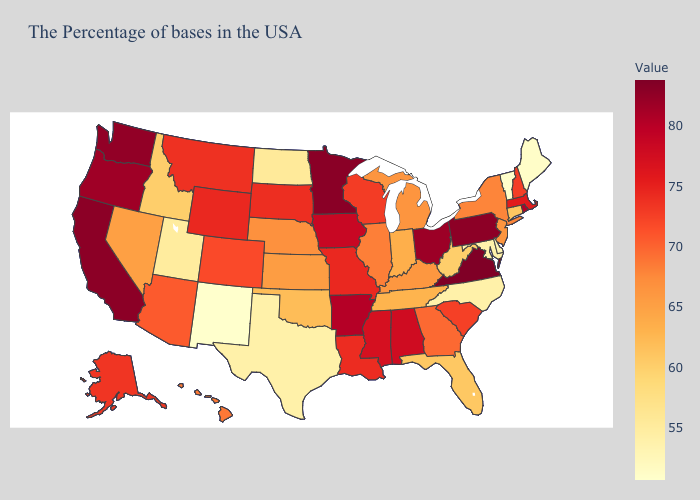Does the map have missing data?
Write a very short answer. No. Does New Mexico have the lowest value in the West?
Be succinct. Yes. Among the states that border Tennessee , does Georgia have the highest value?
Give a very brief answer. No. Which states have the highest value in the USA?
Write a very short answer. Virginia. 